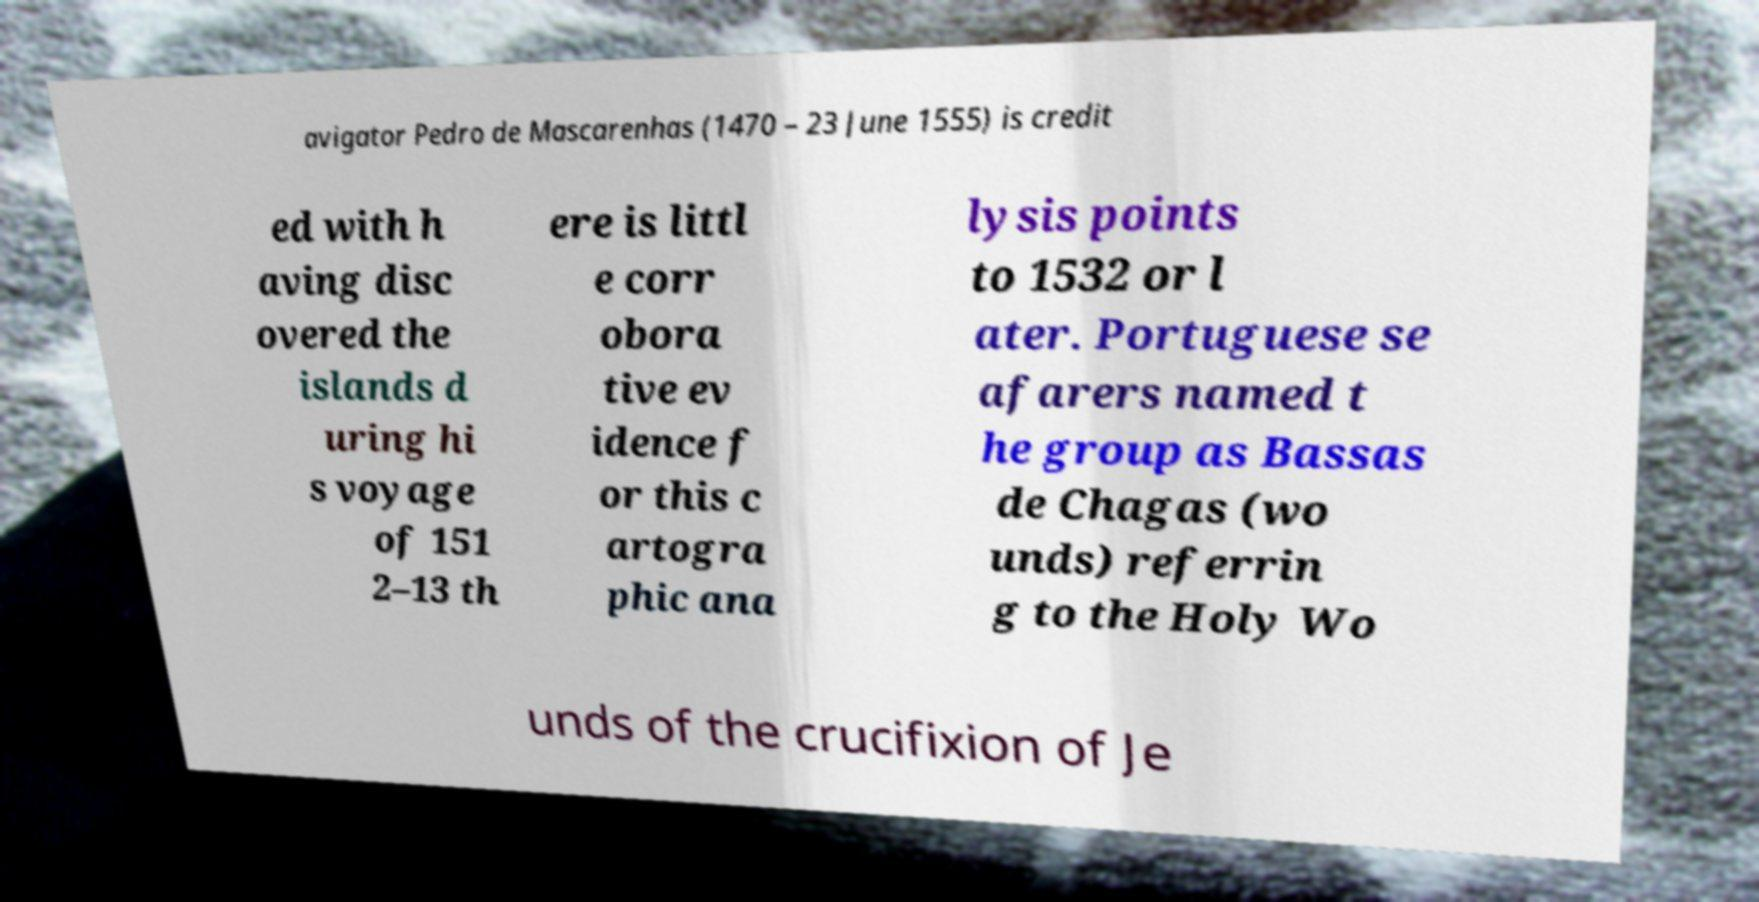For documentation purposes, I need the text within this image transcribed. Could you provide that? avigator Pedro de Mascarenhas (1470 – 23 June 1555) is credit ed with h aving disc overed the islands d uring hi s voyage of 151 2–13 th ere is littl e corr obora tive ev idence f or this c artogra phic ana lysis points to 1532 or l ater. Portuguese se afarers named t he group as Bassas de Chagas (wo unds) referrin g to the Holy Wo unds of the crucifixion of Je 